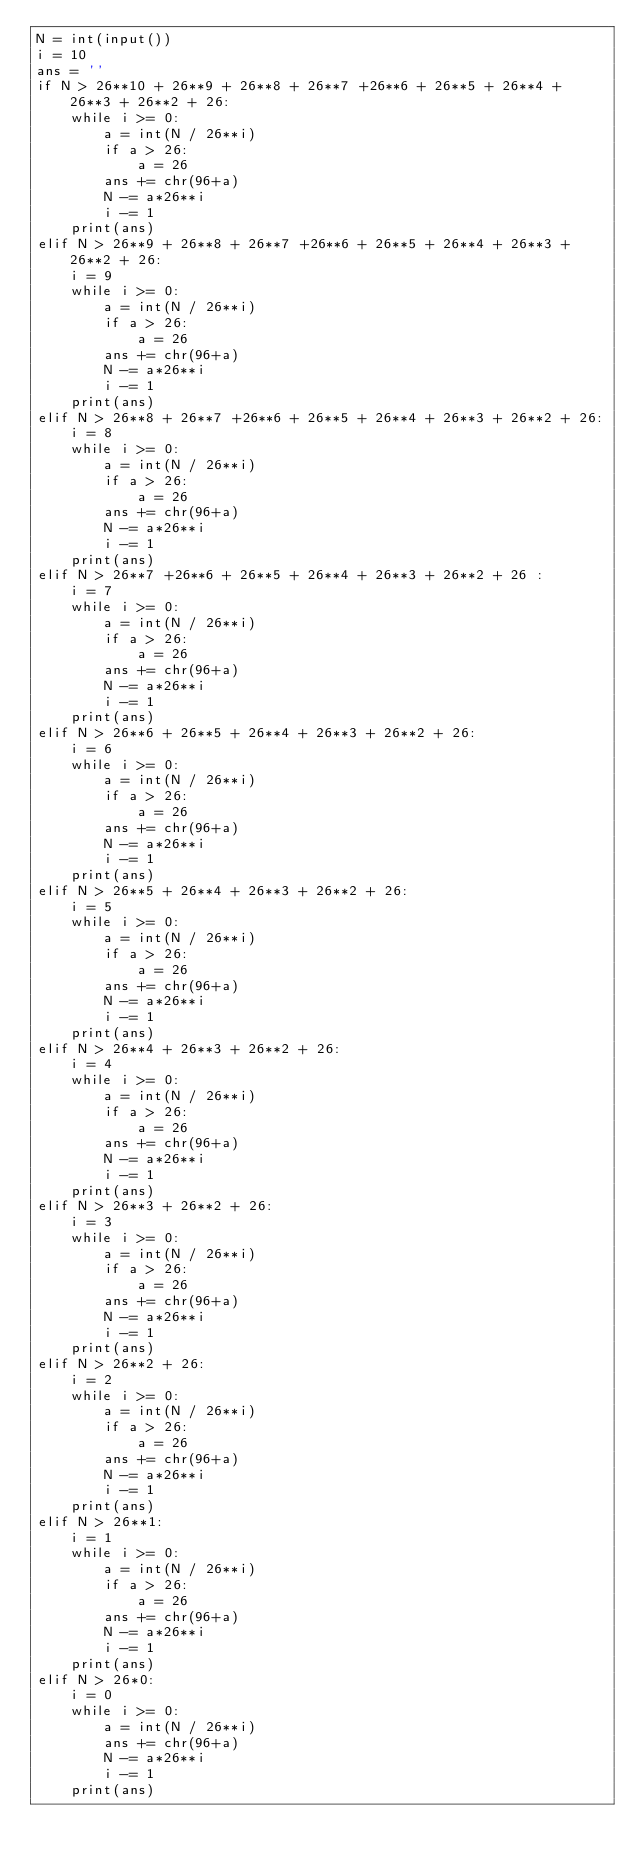Convert code to text. <code><loc_0><loc_0><loc_500><loc_500><_Python_>N = int(input())
i = 10
ans = ''
if N > 26**10 + 26**9 + 26**8 + 26**7 +26**6 + 26**5 + 26**4 + 26**3 + 26**2 + 26:
    while i >= 0:
        a = int(N / 26**i)
        if a > 26:
            a = 26
        ans += chr(96+a)
        N -= a*26**i
        i -= 1
    print(ans)
elif N > 26**9 + 26**8 + 26**7 +26**6 + 26**5 + 26**4 + 26**3 + 26**2 + 26:
    i = 9
    while i >= 0:
        a = int(N / 26**i)
        if a > 26:
            a = 26
        ans += chr(96+a)
        N -= a*26**i
        i -= 1
    print(ans)
elif N > 26**8 + 26**7 +26**6 + 26**5 + 26**4 + 26**3 + 26**2 + 26:
    i = 8
    while i >= 0:
        a = int(N / 26**i)
        if a > 26:
            a = 26
        ans += chr(96+a)
        N -= a*26**i
        i -= 1
    print(ans)
elif N > 26**7 +26**6 + 26**5 + 26**4 + 26**3 + 26**2 + 26 :
    i = 7
    while i >= 0:
        a = int(N / 26**i)
        if a > 26:
            a = 26
        ans += chr(96+a)
        N -= a*26**i
        i -= 1
    print(ans)
elif N > 26**6 + 26**5 + 26**4 + 26**3 + 26**2 + 26:
    i = 6
    while i >= 0:
        a = int(N / 26**i)
        if a > 26:
            a = 26
        ans += chr(96+a)
        N -= a*26**i
        i -= 1
    print(ans)
elif N > 26**5 + 26**4 + 26**3 + 26**2 + 26:
    i = 5
    while i >= 0:
        a = int(N / 26**i)
        if a > 26:
            a = 26
        ans += chr(96+a)
        N -= a*26**i
        i -= 1
    print(ans)
elif N > 26**4 + 26**3 + 26**2 + 26:
    i = 4
    while i >= 0:
        a = int(N / 26**i)
        if a > 26:
            a = 26
        ans += chr(96+a)
        N -= a*26**i
        i -= 1
    print(ans)
elif N > 26**3 + 26**2 + 26:
    i = 3
    while i >= 0:
        a = int(N / 26**i)
        if a > 26:
            a = 26
        ans += chr(96+a)
        N -= a*26**i
        i -= 1
    print(ans)
elif N > 26**2 + 26:
    i = 2
    while i >= 0:
        a = int(N / 26**i)
        if a > 26:
            a = 26
        ans += chr(96+a)
        N -= a*26**i
        i -= 1
    print(ans)
elif N > 26**1:
    i = 1
    while i >= 0:
        a = int(N / 26**i) 
        if a > 26:
            a = 26
        ans += chr(96+a)
        N -= a*26**i
        i -= 1
    print(ans)
elif N > 26*0:
    i = 0
    while i >= 0:
        a = int(N / 26**i)
        ans += chr(96+a)
        N -= a*26**i
        i -= 1
    print(ans)</code> 